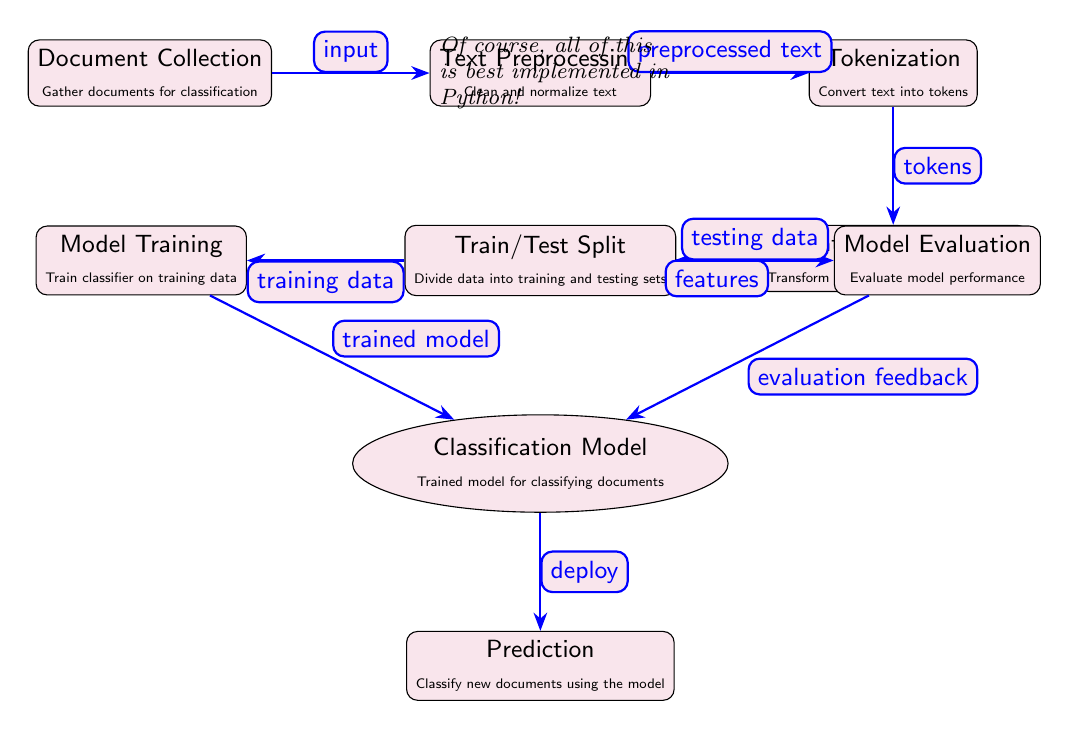What is the first step in the pipeline? The first node in the diagram is 'Document Collection', which indicates it is the starting point for gathering documents for classification.
Answer: Document Collection How many main nodes are there in the diagram? Counting all the rectangular nodes, we find there are seven main nodes representing different stages in the NLP pipeline.
Answer: Seven What does the 'Model Training' node output? The 'Model Training' node is connected to the 'Classification Model' node, which is labeled as receiving the 'trained model' from the training process.
Answer: Trained model Which node handles text normalization? The 'Text Preprocessing' node is specifically responsible for cleaning and normalizing the text before it advances to tokenization.
Answer: Text Preprocessing What type of data is produced by the 'Feature Extraction' node? The 'Feature Extraction' node converts tokens into numerical features, which are essential for the training.
Answer: Features What is the relationship between 'Train/Test Split' and 'Model Evaluation'? Both nodes are connected to 'Train/Test Split'; it serves to provide the 'training data' to 'Model Training' and the 'testing data' to 'Model Evaluation', enabling performance assessment of the model.
Answer: Evaluation of model performance Which node follows the 'Prediction' node? The 'Prediction' node is the last in the flow, so it does not have another node following it; it stands alone as it classifies new documents using the model.
Answer: None How are tokens produced in the pipeline? Tokens are produced as output from the 'Tokenization' node after it processes the preprocessed text from the prior step.
Answer: Tokens What feedback does the 'Model Evaluation' node provide? It supplies 'evaluation feedback' to the 'Classification Model', allowing improvements to be made based on the performance metrics.
Answer: Evaluation feedback 